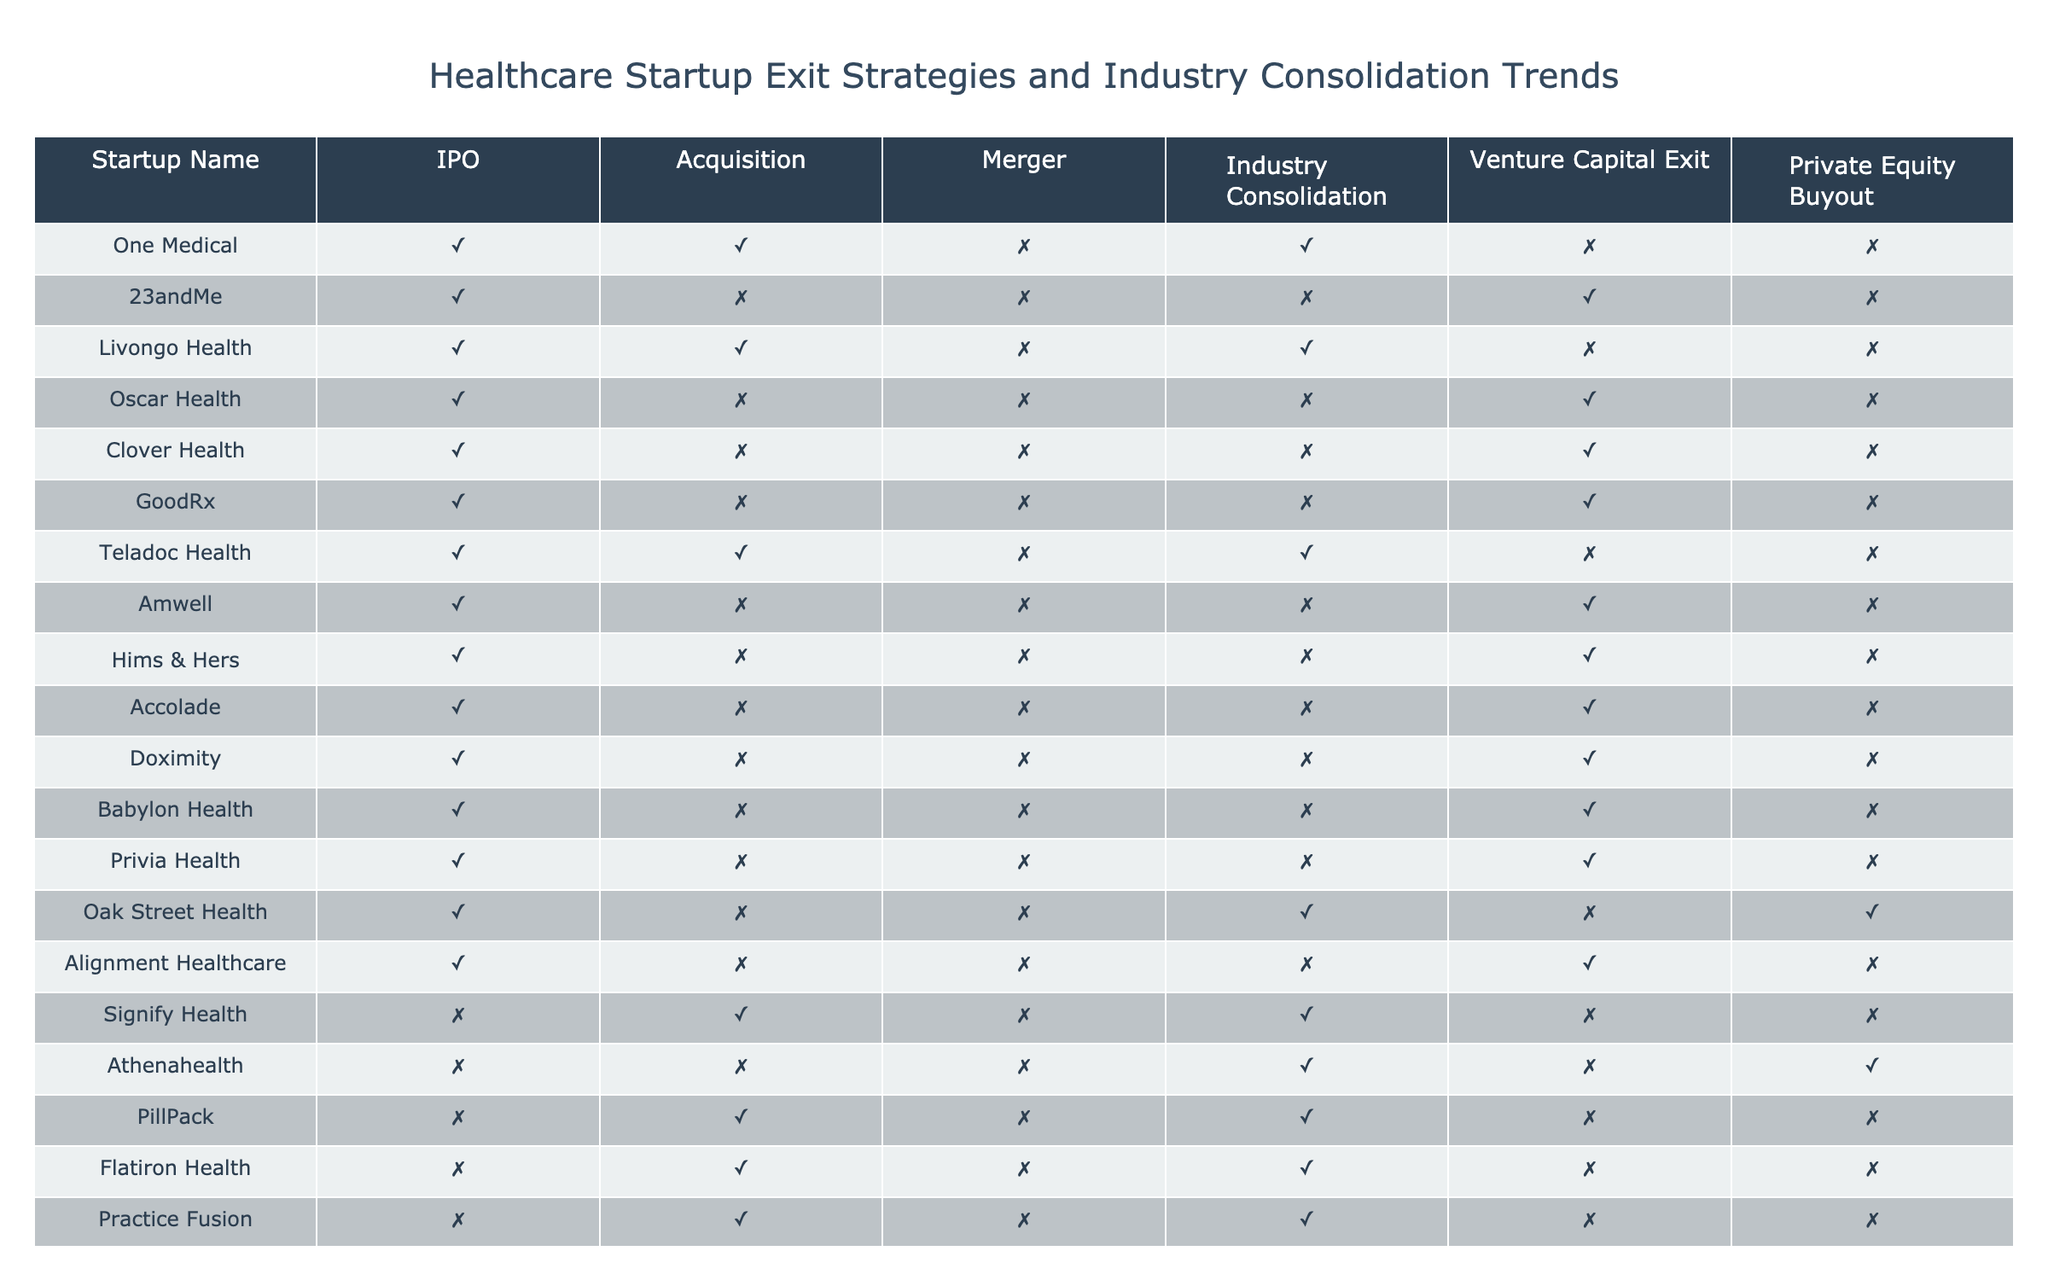What startups have pursued both IPO and acquisition? By checking the table, I see that One Medical and Livongo Health are listed with "TRUE" for both IPO and Acquisition. These are the only two startups that meet both criteria.
Answer: One Medical, Livongo Health How many startups have undergone an acquisition as part of their exit strategy? I can find the number of startups marked as "TRUE" in the Acquisition column. There are a total of 5 (One Medical, Livongo Health, Signify Health, PillPack, Flatiron Health) startups that have pursued acquisition.
Answer: 5 Which startup has not pursued any exit strategy as IPO or acquisition? I can verify under the IPO and Acquisition columns to check for a startup that has "FALSE" in both categories. In this case, there are no startups identified that fit this description as all listed startups have pursued IPO.
Answer: None Is there any startup that has undergone a Private Equity Buyout? I can look at the Private Equity Buyout column and check for any entries marked as "TRUE." According to the table, only one startup, Oak Street Health, displays "TRUE" for Private Equity Buyout.
Answer: Yes, Oak Street Health What is the total number of startups that have engaged in industry consolidation trends? By summing the instances marked as "TRUE" in the Industry Consolidation column, I see there are 6 startups (One Medical, Livongo Health, Teladoc Health, Signify Health, Athenahealth, PillPack) that have engaged in industry consolidation trends.
Answer: 6 For which startups is the Venture Capital Exit strategy marked as "TRUE"? Observing the Venture Capital Exit column, I see that 23andMe, Oscar Health, Clover Health, GoodRx, Amwell, Hims & Hers, Accolade, Doximity, Babylon Health, and Alignment Healthcare have "TRUE" entries for this exit strategy.
Answer: 23andMe, Oscar Health, Clover Health, GoodRx, Amwell, Hims & Hers, Accolade, Doximity, Babylon Health, Alignment Healthcare Which merging strategies have been pursued by the startups listed in the table? I scan the Merger column and find that no startup has marked "TRUE." Thus, I conclude that none of the startups listed have pursued a merger strategy.
Answer: None Which exit strategy is the least favorable for the startups in the healthcare sector according to the table? By reviewing the exit strategies, I see that the Merger column has no entries marked as "TRUE," indicating that pursuing mergers is the least favorable exit strategy among the startups in the table.
Answer: Merger is the least favorable exit strategy 